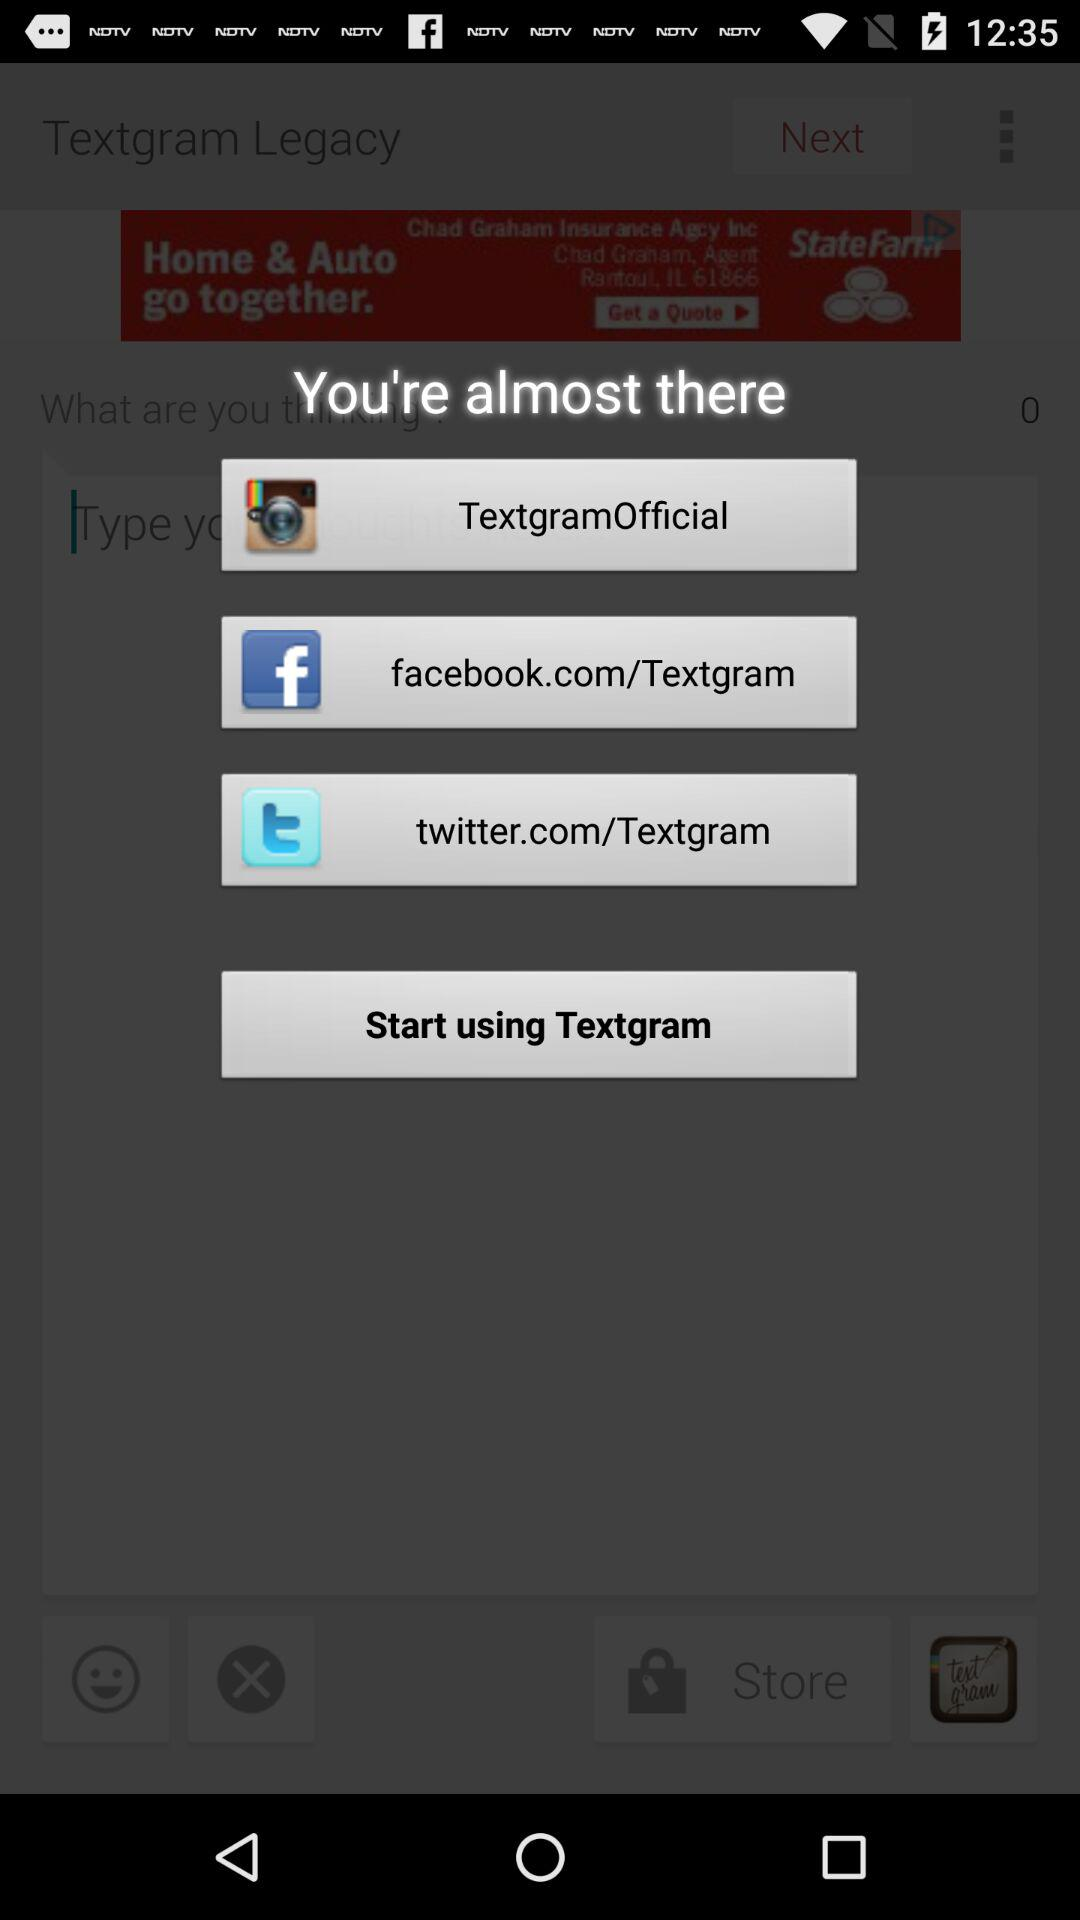What applications can be used to share? The applications are "Textgram", "Facebook" and "Twitter". 